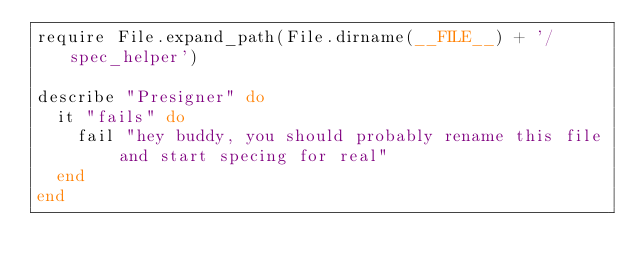<code> <loc_0><loc_0><loc_500><loc_500><_Ruby_>require File.expand_path(File.dirname(__FILE__) + '/spec_helper')

describe "Presigner" do
  it "fails" do
    fail "hey buddy, you should probably rename this file and start specing for real"
  end
end
</code> 